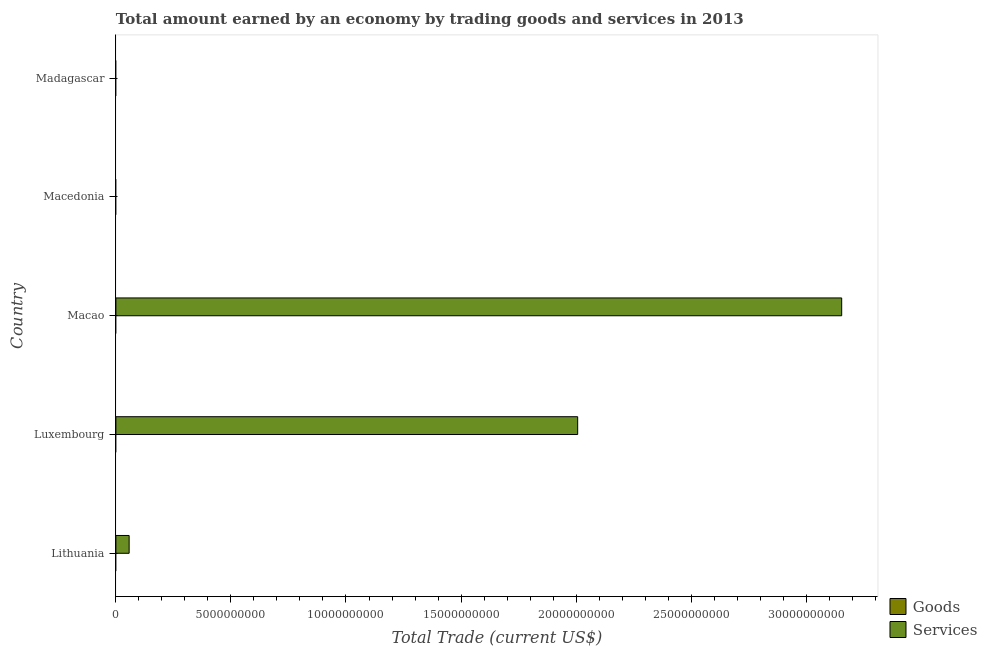How many different coloured bars are there?
Offer a terse response. 1. Are the number of bars per tick equal to the number of legend labels?
Make the answer very short. No. Are the number of bars on each tick of the Y-axis equal?
Offer a terse response. No. How many bars are there on the 2nd tick from the bottom?
Provide a short and direct response. 1. What is the label of the 3rd group of bars from the top?
Your response must be concise. Macao. In how many cases, is the number of bars for a given country not equal to the number of legend labels?
Your answer should be compact. 5. Across all countries, what is the maximum amount earned by trading services?
Provide a succinct answer. 3.15e+1. In which country was the amount earned by trading services maximum?
Keep it short and to the point. Macao. What is the total amount earned by trading goods in the graph?
Your response must be concise. 0. What is the difference between the amount earned by trading services in Lithuania and that in Luxembourg?
Your answer should be compact. -1.95e+1. What is the difference between the amount earned by trading goods in Luxembourg and the amount earned by trading services in Macao?
Your response must be concise. -3.15e+1. What is the average amount earned by trading services per country?
Your answer should be compact. 1.04e+1. In how many countries, is the amount earned by trading services greater than 25000000000 US$?
Make the answer very short. 1. Is the amount earned by trading services in Luxembourg less than that in Macao?
Provide a succinct answer. Yes. What is the difference between the highest and the second highest amount earned by trading services?
Provide a succinct answer. 1.15e+1. What is the difference between the highest and the lowest amount earned by trading services?
Provide a short and direct response. 3.15e+1. In how many countries, is the amount earned by trading services greater than the average amount earned by trading services taken over all countries?
Keep it short and to the point. 2. Are all the bars in the graph horizontal?
Give a very brief answer. Yes. How many countries are there in the graph?
Your answer should be very brief. 5. Are the values on the major ticks of X-axis written in scientific E-notation?
Provide a succinct answer. No. Does the graph contain any zero values?
Offer a very short reply. Yes. What is the title of the graph?
Offer a terse response. Total amount earned by an economy by trading goods and services in 2013. What is the label or title of the X-axis?
Offer a terse response. Total Trade (current US$). What is the label or title of the Y-axis?
Offer a terse response. Country. What is the Total Trade (current US$) in Goods in Lithuania?
Give a very brief answer. 0. What is the Total Trade (current US$) of Services in Lithuania?
Make the answer very short. 5.76e+08. What is the Total Trade (current US$) of Goods in Luxembourg?
Give a very brief answer. 0. What is the Total Trade (current US$) in Services in Luxembourg?
Offer a very short reply. 2.01e+1. What is the Total Trade (current US$) in Services in Macao?
Your answer should be very brief. 3.15e+1. What is the Total Trade (current US$) in Goods in Macedonia?
Make the answer very short. 0. What is the Total Trade (current US$) of Services in Macedonia?
Provide a succinct answer. 0. What is the Total Trade (current US$) of Services in Madagascar?
Ensure brevity in your answer.  0. Across all countries, what is the maximum Total Trade (current US$) in Services?
Offer a very short reply. 3.15e+1. Across all countries, what is the minimum Total Trade (current US$) in Services?
Ensure brevity in your answer.  0. What is the total Total Trade (current US$) of Services in the graph?
Your response must be concise. 5.22e+1. What is the difference between the Total Trade (current US$) of Services in Lithuania and that in Luxembourg?
Provide a succinct answer. -1.95e+1. What is the difference between the Total Trade (current US$) in Services in Lithuania and that in Macao?
Your answer should be very brief. -3.10e+1. What is the difference between the Total Trade (current US$) in Services in Luxembourg and that in Macao?
Provide a short and direct response. -1.15e+1. What is the average Total Trade (current US$) in Services per country?
Provide a succinct answer. 1.04e+1. What is the ratio of the Total Trade (current US$) of Services in Lithuania to that in Luxembourg?
Keep it short and to the point. 0.03. What is the ratio of the Total Trade (current US$) of Services in Lithuania to that in Macao?
Give a very brief answer. 0.02. What is the ratio of the Total Trade (current US$) in Services in Luxembourg to that in Macao?
Give a very brief answer. 0.64. What is the difference between the highest and the second highest Total Trade (current US$) in Services?
Give a very brief answer. 1.15e+1. What is the difference between the highest and the lowest Total Trade (current US$) in Services?
Keep it short and to the point. 3.15e+1. 